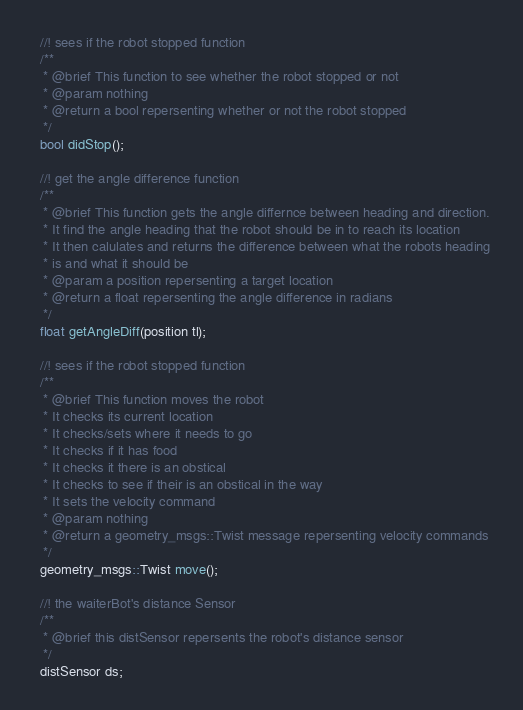Convert code to text. <code><loc_0><loc_0><loc_500><loc_500><_C++_>  //! sees if the robot stopped function
  /**
   * @brief This function to see whether the robot stopped or not
   * @param nothing
   * @return a bool repersenting whether or not the robot stopped
   */
  bool didStop();

  //! get the angle difference function
  /**
   * @brief This function gets the angle differnce between heading and direction.
   * It find the angle heading that the robot should be in to reach its location
   * It then calulates and returns the difference between what the robots heading
   * is and what it should be
   * @param a position repersenting a target location
   * @return a float repersenting the angle difference in radians
   */
  float getAngleDiff(position tl);

  //! sees if the robot stopped function
  /**
   * @brief This function moves the robot
   * It checks its current location
   * It checks/sets where it needs to go
   * It checks if it has food
   * It checks it there is an obstical
   * It checks to see if their is an obstical in the way
   * It sets the velocity command
   * @param nothing
   * @return a geometry_msgs::Twist message repersenting velocity commands
   */
  geometry_msgs::Twist move();

  //! the waiterBot's distance Sensor
  /**
   * @brief this distSensor repersents the robot's distance sensor 
   */
  distSensor ds;
</code> 